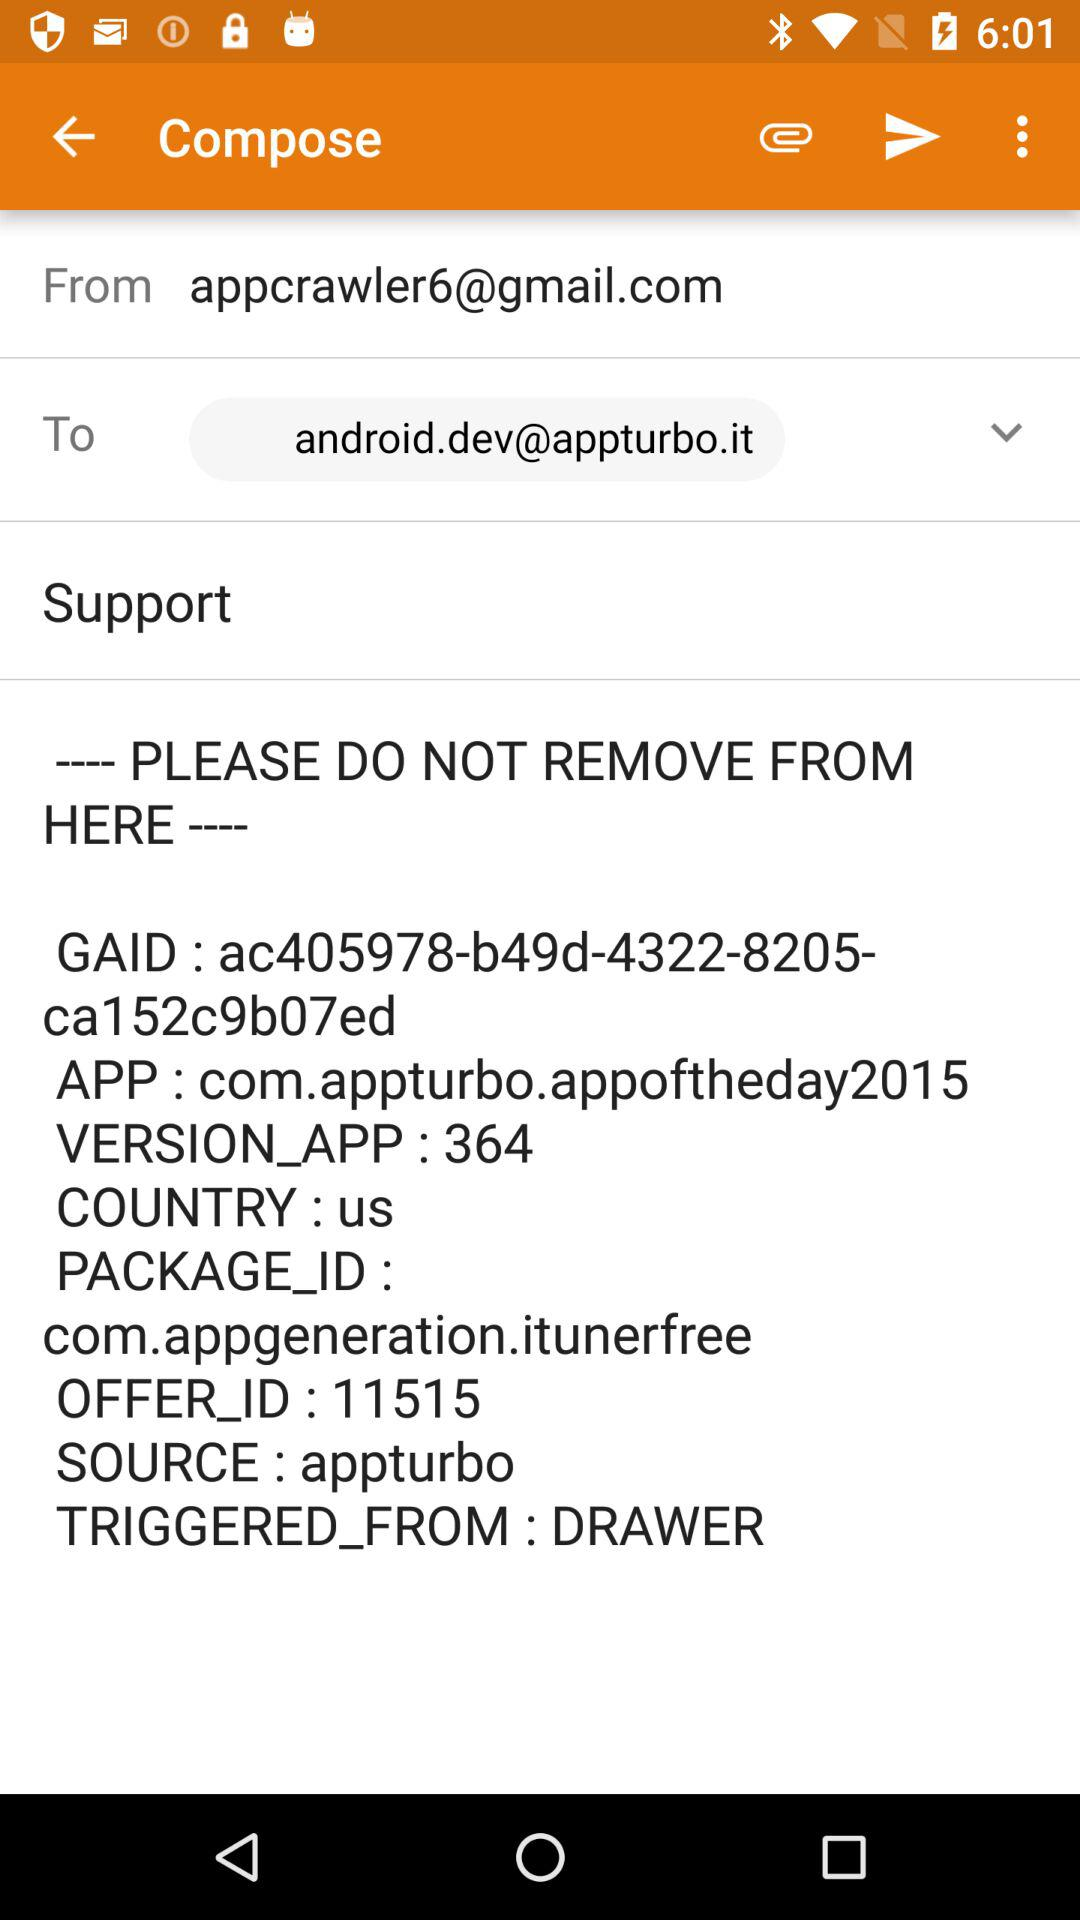Who is the recipient of the mail? The recipient of the mail is android.dev@appturbo.it. 